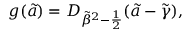<formula> <loc_0><loc_0><loc_500><loc_500>g ( \tilde { a } ) = D _ { { \tilde { \beta } } ^ { 2 } - { \frac { 1 } { 2 } } } ( \tilde { a } - \tilde { \gamma } ) ,</formula> 